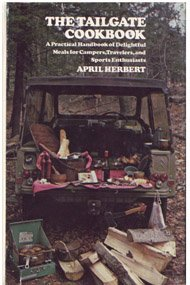Who authored 'The Tailgate Cookbook' and what might be their culinary background? The book is authored by April Herbert. Judging by the book's content and focus, April likely has experience or a keen interest in creating recipes that are both delicious and suitable for outdoor gatherings. What makes this cookbook unique compared to other cookbooks? What sets 'The Tailgate Cookbook' apart is its focus on tailgating cuisine, which not only includes recipes but also covers the nuances of preparing and enjoying food in an outdoor and transient setting like a sports event. 